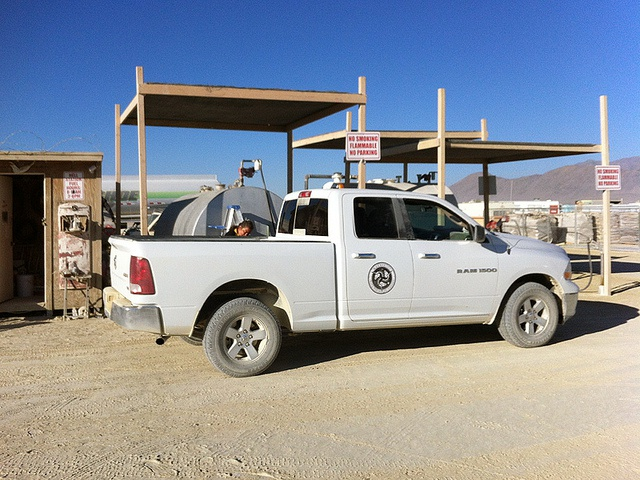Describe the objects in this image and their specific colors. I can see truck in darkblue, lightgray, black, darkgray, and gray tones and people in darkblue, black, maroon, and salmon tones in this image. 